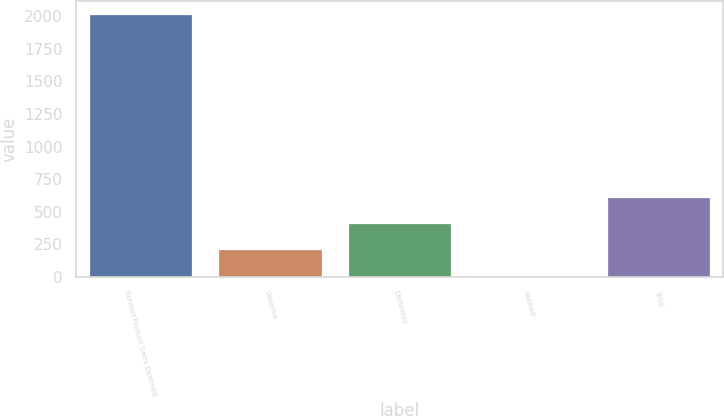Convert chart to OTSL. <chart><loc_0><loc_0><loc_500><loc_500><bar_chart><fcel>Refined Product Sales Destined<fcel>Gasoline<fcel>Distillates<fcel>Asphalt<fcel>Total<nl><fcel>2017<fcel>209.8<fcel>410.6<fcel>9<fcel>611.4<nl></chart> 